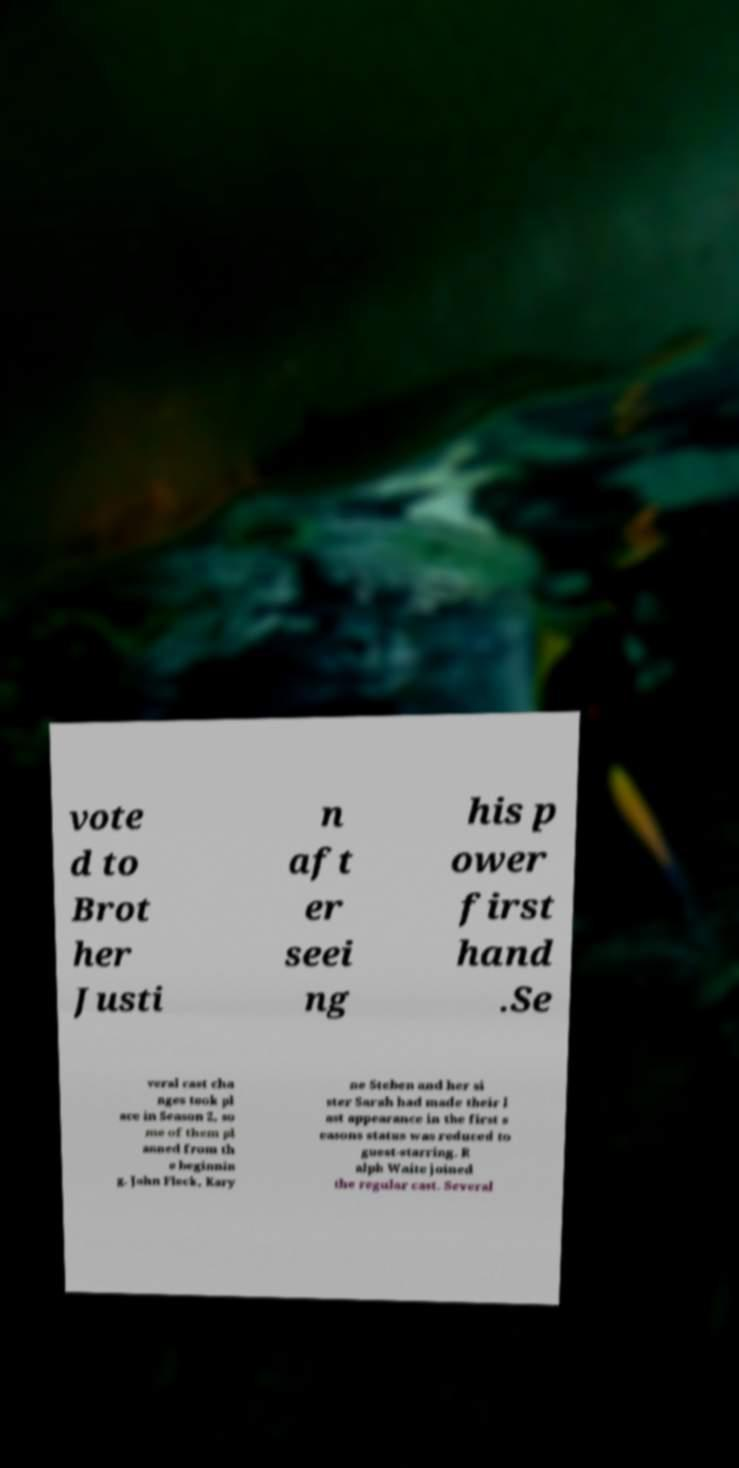Could you assist in decoding the text presented in this image and type it out clearly? vote d to Brot her Justi n aft er seei ng his p ower first hand .Se veral cast cha nges took pl ace in Season 2, so me of them pl anned from th e beginnin g. John Fleck, Kary ne Steben and her si ster Sarah had made their l ast appearance in the first s easons status was reduced to guest-starring. R alph Waite joined the regular cast. Several 